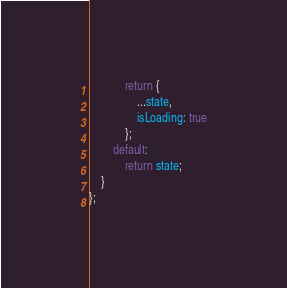Convert code to text. <code><loc_0><loc_0><loc_500><loc_500><_JavaScript_>            return {
                ...state,
                isLoading: true
            };
        default:
            return state;
    }
};</code> 